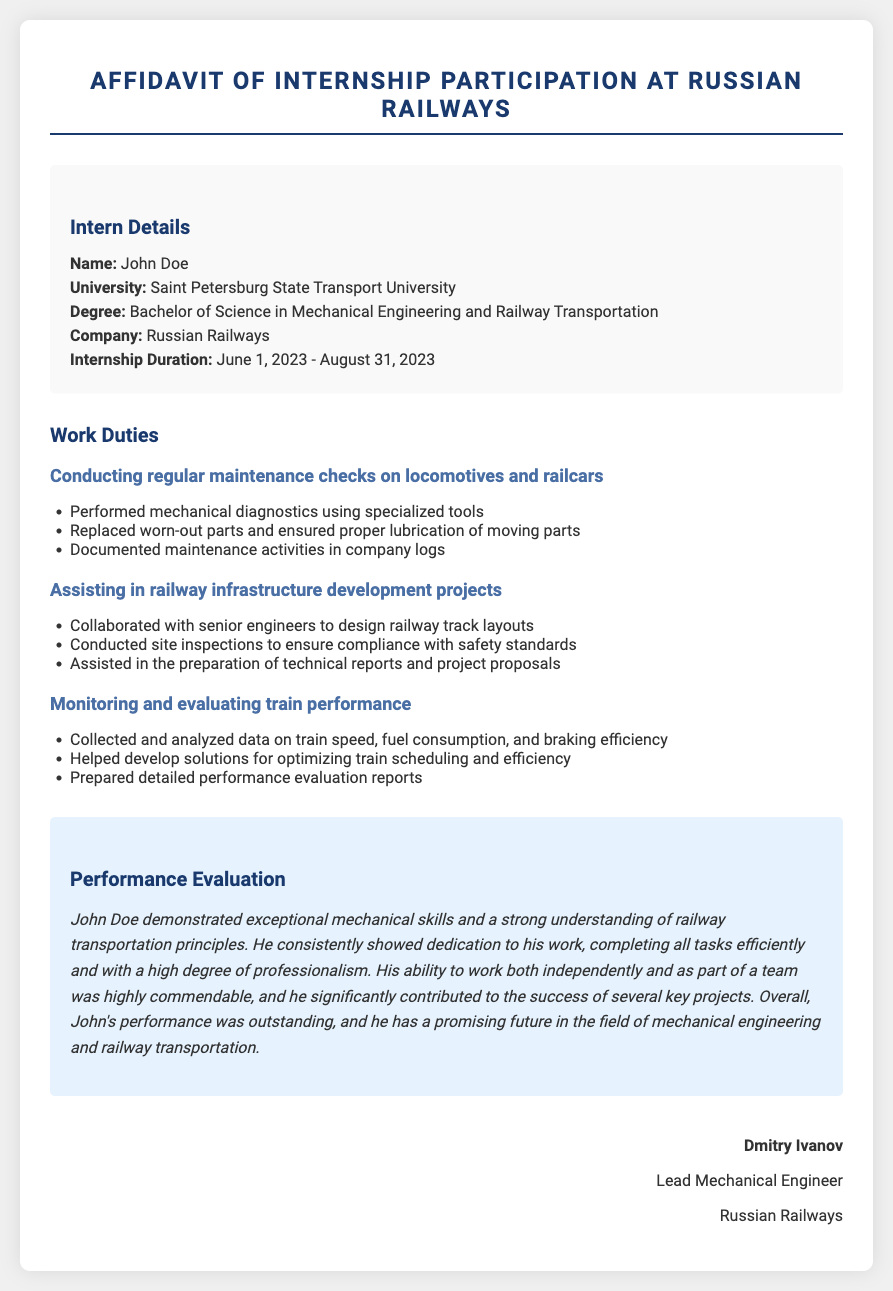What is the name of the intern? The intern's name is specifically mentioned in the document.
Answer: John Doe What university does the intern attend? The document provides the name of the university where the intern is studying.
Answer: Saint Petersburg State Transport University What is the duration of the internship? This is a specific date range mentioned in the document.
Answer: June 1, 2023 - August 31, 2023 Which company did the intern work for? The document clearly states the name of the company where the internship took place.
Answer: Russian Railways What was one of the work duties performed by the intern? The document lists several work duties; one can be retrieved from that list.
Answer: Conducting regular maintenance checks on locomotives and railcars What skills did the intern demonstrate during the internship? The performance evaluation section describes the skills showcased by the intern.
Answer: Exceptional mechanical skills Who evaluated the intern's performance? The performance evaluation includes the name of the evaluator.
Answer: Dmitry Ivanov What was the intern’s degree program? The degree program is specified in the intern details section.
Answer: Bachelor of Science in Mechanical Engineering and Railway Transportation What role did Dmitry Ivanov hold in the company? This is explicitly stated in the document following his name in the signature section.
Answer: Lead Mechanical Engineer 